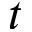<formula> <loc_0><loc_0><loc_500><loc_500>t</formula> 